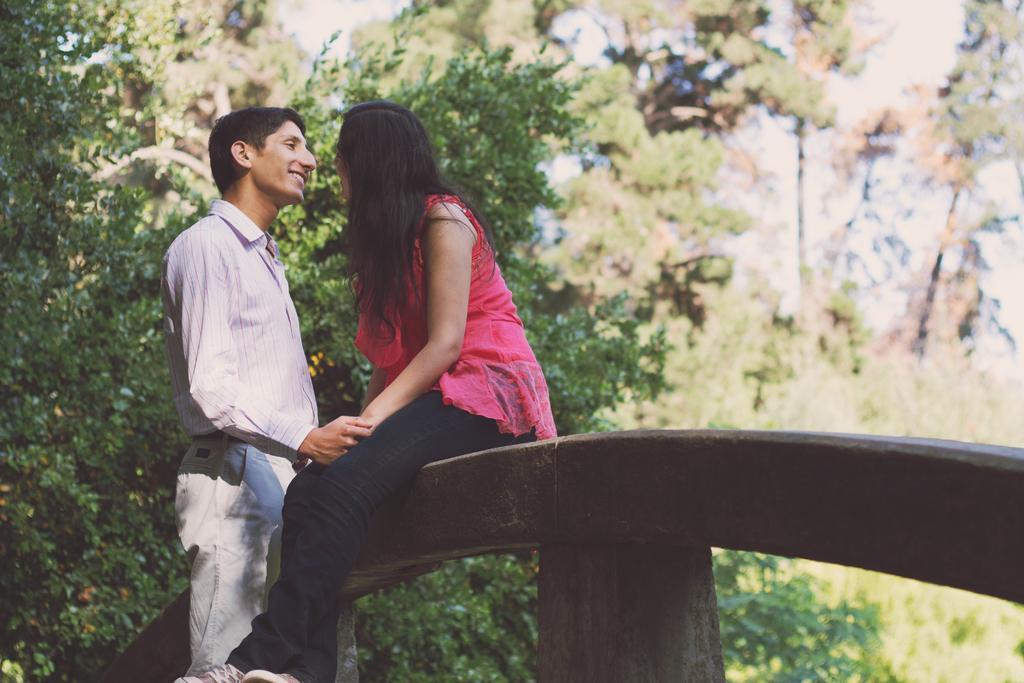In one or two sentences, can you explain what this image depicts? This image consists of two persons. The woman is sitting on a wooden block. She is wearing a pink dress. In the background, there are many trees. The man is wearing a formal dress. 